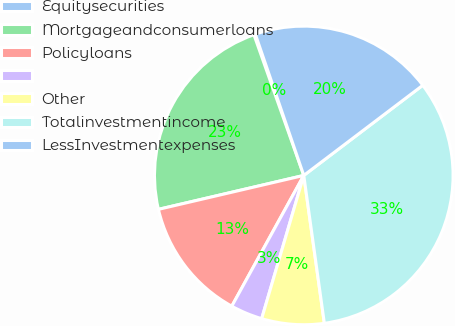<chart> <loc_0><loc_0><loc_500><loc_500><pie_chart><fcel>Equitysecurities<fcel>Mortgageandconsumerloans<fcel>Policyloans<fcel>Unnamed: 3<fcel>Other<fcel>Totalinvestmentincome<fcel>LessInvestmentexpenses<nl><fcel>0.16%<fcel>23.23%<fcel>13.34%<fcel>3.46%<fcel>6.75%<fcel>33.12%<fcel>19.94%<nl></chart> 